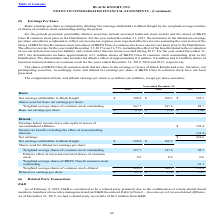According to Black Knight Financial Services's financial document, How did the company compute basic earnings per share? dividing Net earnings attributable to Black Knight by the weighted-average number of shares of common stock outstanding during the period.. The document states: "Basic earnings per share is computed by dividing Net earnings attributable to Black Knight by the weighted-average number of shares of common stock ou..." Also, What years does the table provide information for the computation of basic and diluted earnings per share is as follows (in millions, except per share? The document contains multiple relevant values: 2019, 2018, 2017. From the document: "2019 2018 2017 2019 2018 2017 2019 2018 2017..." Also, What were the basic Net earnings attributable to Black Knight in 2017? According to the financial document, 182.3 (in millions). The relevant text states: "gs attributable to Black Knight $ 108.8 $ 168.5 $ 182.3..." Also, can you calculate: What was the change in the basic net earnings attributable to Black Knight between 2017 and 2018? Based on the calculation: 168.5-182.3, the result is -13.8 (in millions). This is based on the information: "t earnings attributable to Black Knight $ 108.8 $ 168.5 $ 182.3 gs attributable to Black Knight $ 108.8 $ 168.5 $ 182.3..." The key data points involved are: 168.5, 182.3. Also, can you calculate: What was the change in the basic net earnings per share between 2017 and 2019? Based on the calculation: 0.74-2.06, the result is -1.32. This is based on the information: "Basic net earnings per share $ 0.74 $ 1.14 $ 2.06 Basic net earnings per share $ 0.74 $ 1.14 $ 2.06..." The key data points involved are: 0.74, 2.06. Also, can you calculate: What was the percentage change in Diluted net earnings per share between 2018 and 2019? To answer this question, I need to perform calculations using the financial data. The calculation is: (0.73-1.14)/1.14, which equals -35.96 (percentage). This is based on the information: "Diluted net earnings per share $ 0.73 $ 1.14 $ 1.47 Basic net earnings per share $ 0.74 $ 1.14 $ 2.06..." The key data points involved are: 0.73, 1.14. 